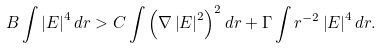Convert formula to latex. <formula><loc_0><loc_0><loc_500><loc_500>B \int \left | E \right | ^ { 4 } d r > C \int \left ( \nabla \left | E \right | ^ { 2 } \right ) ^ { 2 } d r + \Gamma \int r ^ { - 2 } \left | E \right | ^ { 4 } d r .</formula> 